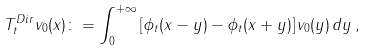<formula> <loc_0><loc_0><loc_500><loc_500>T ^ { D i r } _ { t } v _ { 0 } ( x ) \colon = \int _ { 0 } ^ { + \infty } \left [ \phi _ { t } ( x - y ) - \phi _ { t } ( x + y ) \right ] v _ { 0 } ( y ) \, d y \, ,</formula> 